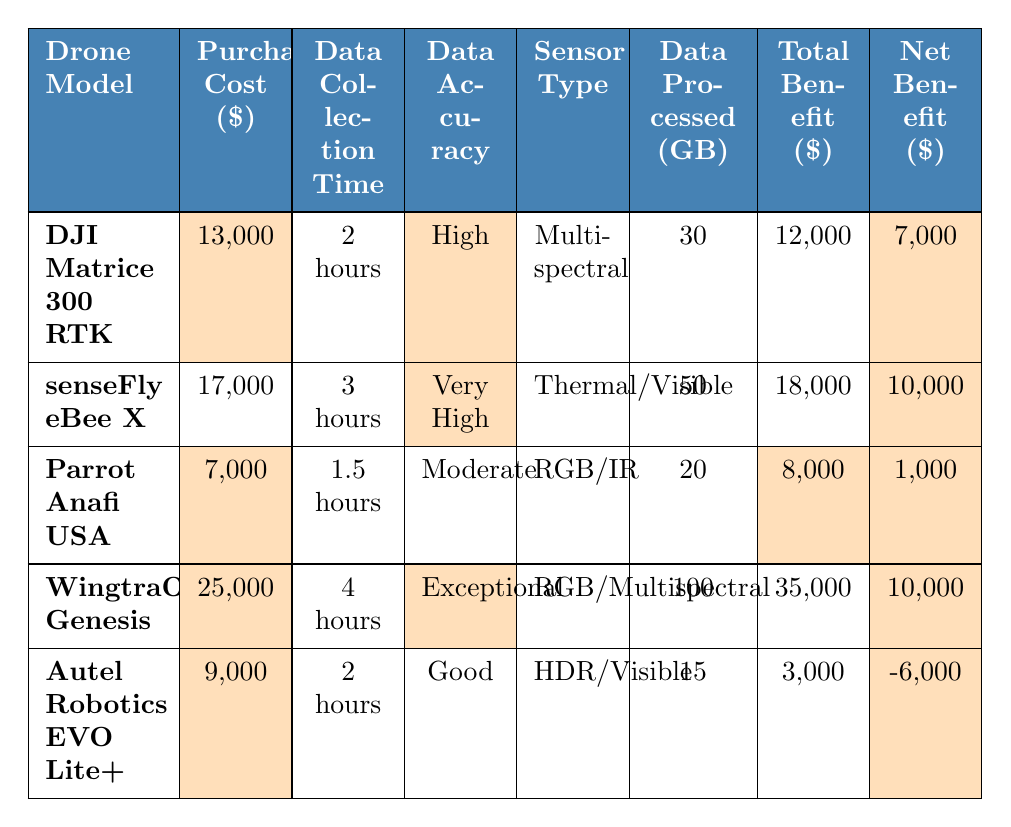What is the purchase cost of the DJI Matrice 300 RTK? Looking at the table, the purchase cost for the DJI Matrice 300 RTK is highlighted and listed as 13,000.
Answer: 13,000 Which drone model has the highest net benefit? By examining the net benefit values in the table, both the senseFly eBee X and the WingtraOne Genesis have the highest net benefit at 10,000, but senseFly eBee X has higher purchase cost.
Answer: senseFly eBee X and WingtraOne Genesis (10,000) What is the operational cost per hour for the Autel Robotics EVO Lite+? The operational cost per hour for the Autel Robotics EVO Lite+ is not explicitly highlighted but can be found in the table as 100.
Answer: 100 How many gigabytes of data can the WingtraOne Genesis process? The WingtraOne Genesis can process a total of 100 GB of data, which is specified in the table under data processed.
Answer: 100 GB Which drone has the lowest purchase cost? The lowest purchase cost is found by comparing all models in the purchase cost column; the Parrot Anafi USA has the lowest at 7,000.
Answer: 7,000 What is the total benefit of the drone that processes 15 GB of data? The Autel Robotics EVO Lite+ processes 15 GB of data, and its total benefit is highlighted in the table as 3,000.
Answer: 3,000 Is there a drone model with a negative net benefit? Yes, the Autel Robotics EVO Lite+ has a negative net benefit of -6,000, which is clearly indicated in the table.
Answer: Yes Calculate the average purchase cost of all drone models listed. The purchase costs are 13,000, 17,000, 7,000, 25,000, and 9,000. Their sum is 71,000. Dividing by the number of models (5) gives an average of 14,200.
Answer: 14,200 Which drone offers the best data accuracy on the table? The best data accuracy is noted as "Exceptional" for the WingtraOne Genesis, making it the clear leader in the data accuracy category.
Answer: WingtraOne Genesis How much more is the purchase cost of the senseFly eBee X compared to the Parrot Anafi USA? The senseFly eBee X purchase cost is 17,000 and the Parrot Anafi USA is 7,000. The difference gives 17,000 - 7,000 = 10,000.
Answer: 10,000 